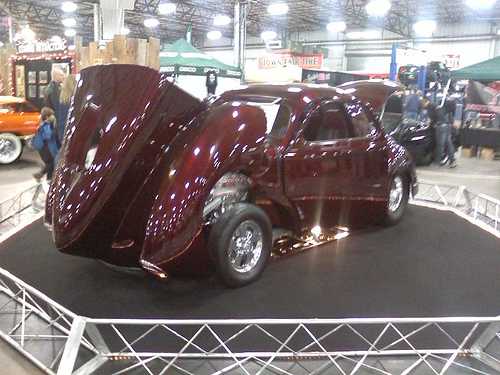<image>
Can you confirm if the hood is above the railing? Yes. The hood is positioned above the railing in the vertical space, higher up in the scene. 